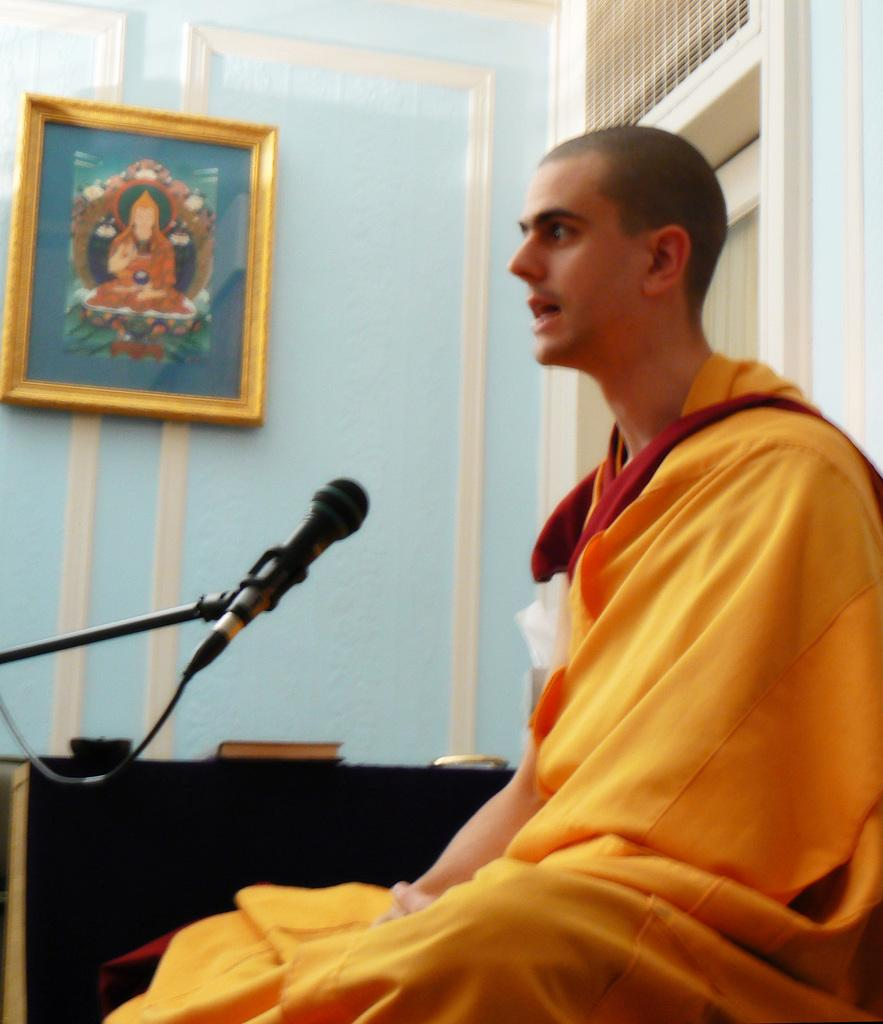Who or what is in the image? There is a person in the image. What is the person doing or interacting with in the image? There is a microphone in front of the person. What can be seen in the background of the image? There is a book, a wall, a photo frame, and other objects visible in the background of the image. How does the person's wealth affect the image? The image does not provide any information about the person's wealth, so it cannot be determined how it affects the image. 